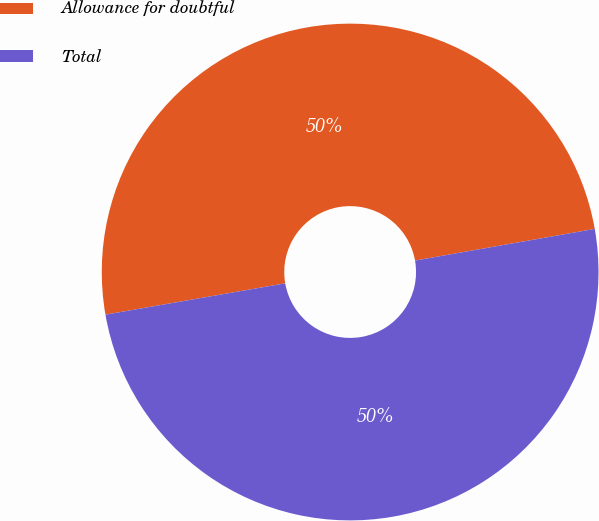<chart> <loc_0><loc_0><loc_500><loc_500><pie_chart><fcel>Allowance for doubtful<fcel>Total<nl><fcel>49.97%<fcel>50.03%<nl></chart> 